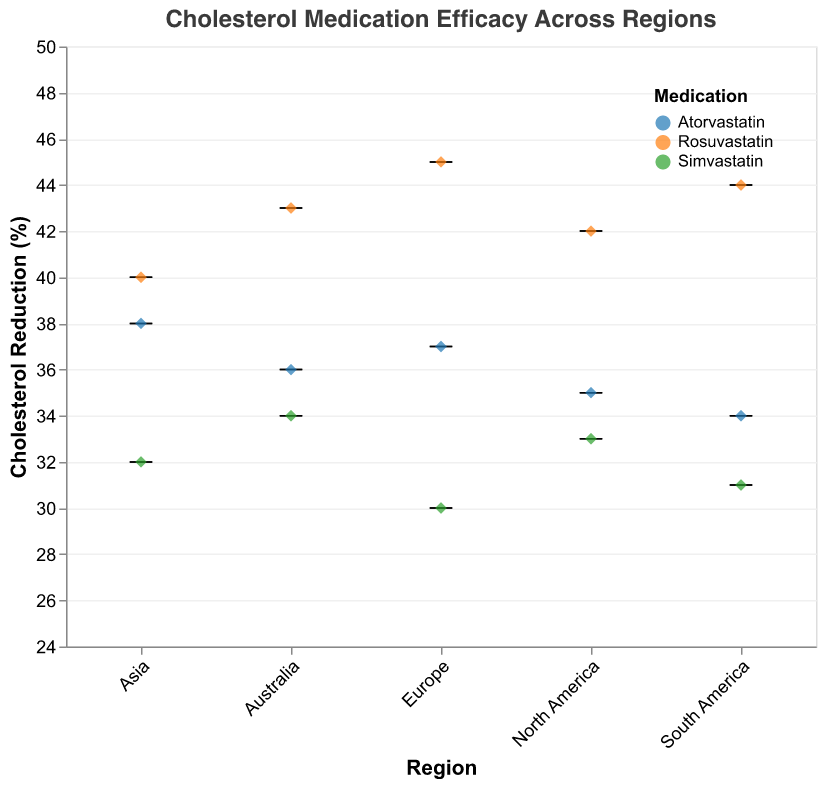What is the title of the figure? The title of the figure can be found at the top of the plot, usually in a larger font size for emphasis. It reads "Cholesterol Medication Efficacy Across Regions".
Answer: Cholesterol Medication Efficacy Across Regions Which medication has the highest mean cholesterol reduction in Europe? By looking at the y-axis values within the Europe category and comparing the mean values represented by the colored box plots for each medication, Rosuvastatin shows the highest mean reduction.
Answer: Rosuvastatin What is the mean cholesterol reduction for Atorvastatin in Australia? The position of the Atorvastatin marker within the Australia category shows the mean reduction on the y-axis, which is 36%.
Answer: 36% Which region has the smallest variability in cholesterol reduction for Atorvastatin? Variability can be assessed by looking at the height of the box plots for Atorvastatin across regions. Europe has the smallest box height, indicating less variability.
Answer: Europe Does Rosuvastatin consistently have a higher mean cholesterol reduction compared to Simvastatin across all regions? By comparing the mean values of the box plots for Rosuvastatin and Simvastatin in each region, Rosuvastatin consistently shows a higher mean reduction.
Answer: Yes Which medication has the largest range of cholesterol reduction in North America? The extent of the box plots indicates the range (from minimum to maximum). Simvastatin in North America has the tallest box, indicating the largest range.
Answer: Simvastatin Rank the medications in South America by their mean cholesterol reduction. By reading the height of the mean values for each medication in the South America category, the order from highest to lowest is: Rosuvastatin, Atorvastatin, Simvastatin.
Answer: Rosuvastatin > Atorvastatin > Simvastatin What is the total number of patients taking Simvastatin across all regions? Sum the number of patients for Simvastatin across each region: 120 (North America) + 110 (Europe) + 130 (Asia) + 140 (South America) + 115 (Australia) = 615.
Answer: 615 Which region shows the highest mean reduction for any medication? By comparing the highest points of the mean reductions across all regions and medications, Europe with Rosuvastatin shows the highest mean reduction of 45%.
Answer: Europe What is the difference in mean cholesterol reduction between Rosuvastatin and Atorvastatin in Asia? Subtract the mean reduction of Atorvastatin from Rosuvastatin in Asia: 40% - 38% = 2%.
Answer: 2% 